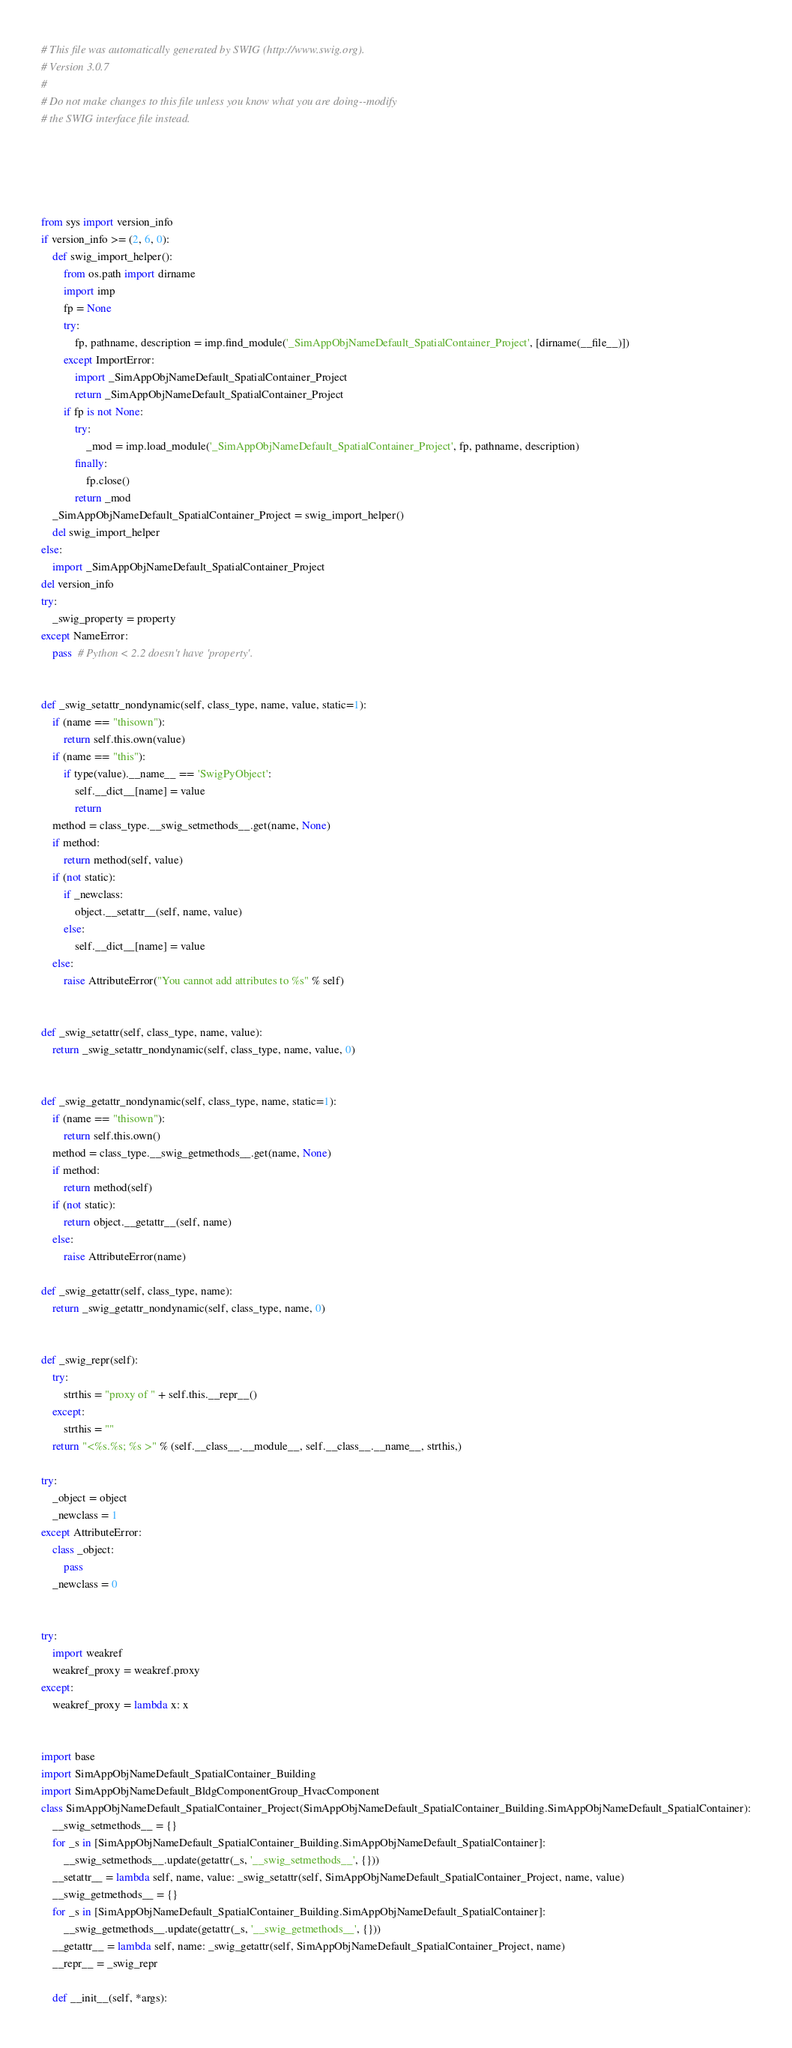Convert code to text. <code><loc_0><loc_0><loc_500><loc_500><_Python_># This file was automatically generated by SWIG (http://www.swig.org).
# Version 3.0.7
#
# Do not make changes to this file unless you know what you are doing--modify
# the SWIG interface file instead.





from sys import version_info
if version_info >= (2, 6, 0):
    def swig_import_helper():
        from os.path import dirname
        import imp
        fp = None
        try:
            fp, pathname, description = imp.find_module('_SimAppObjNameDefault_SpatialContainer_Project', [dirname(__file__)])
        except ImportError:
            import _SimAppObjNameDefault_SpatialContainer_Project
            return _SimAppObjNameDefault_SpatialContainer_Project
        if fp is not None:
            try:
                _mod = imp.load_module('_SimAppObjNameDefault_SpatialContainer_Project', fp, pathname, description)
            finally:
                fp.close()
            return _mod
    _SimAppObjNameDefault_SpatialContainer_Project = swig_import_helper()
    del swig_import_helper
else:
    import _SimAppObjNameDefault_SpatialContainer_Project
del version_info
try:
    _swig_property = property
except NameError:
    pass  # Python < 2.2 doesn't have 'property'.


def _swig_setattr_nondynamic(self, class_type, name, value, static=1):
    if (name == "thisown"):
        return self.this.own(value)
    if (name == "this"):
        if type(value).__name__ == 'SwigPyObject':
            self.__dict__[name] = value
            return
    method = class_type.__swig_setmethods__.get(name, None)
    if method:
        return method(self, value)
    if (not static):
        if _newclass:
            object.__setattr__(self, name, value)
        else:
            self.__dict__[name] = value
    else:
        raise AttributeError("You cannot add attributes to %s" % self)


def _swig_setattr(self, class_type, name, value):
    return _swig_setattr_nondynamic(self, class_type, name, value, 0)


def _swig_getattr_nondynamic(self, class_type, name, static=1):
    if (name == "thisown"):
        return self.this.own()
    method = class_type.__swig_getmethods__.get(name, None)
    if method:
        return method(self)
    if (not static):
        return object.__getattr__(self, name)
    else:
        raise AttributeError(name)

def _swig_getattr(self, class_type, name):
    return _swig_getattr_nondynamic(self, class_type, name, 0)


def _swig_repr(self):
    try:
        strthis = "proxy of " + self.this.__repr__()
    except:
        strthis = ""
    return "<%s.%s; %s >" % (self.__class__.__module__, self.__class__.__name__, strthis,)

try:
    _object = object
    _newclass = 1
except AttributeError:
    class _object:
        pass
    _newclass = 0


try:
    import weakref
    weakref_proxy = weakref.proxy
except:
    weakref_proxy = lambda x: x


import base
import SimAppObjNameDefault_SpatialContainer_Building
import SimAppObjNameDefault_BldgComponentGroup_HvacComponent
class SimAppObjNameDefault_SpatialContainer_Project(SimAppObjNameDefault_SpatialContainer_Building.SimAppObjNameDefault_SpatialContainer):
    __swig_setmethods__ = {}
    for _s in [SimAppObjNameDefault_SpatialContainer_Building.SimAppObjNameDefault_SpatialContainer]:
        __swig_setmethods__.update(getattr(_s, '__swig_setmethods__', {}))
    __setattr__ = lambda self, name, value: _swig_setattr(self, SimAppObjNameDefault_SpatialContainer_Project, name, value)
    __swig_getmethods__ = {}
    for _s in [SimAppObjNameDefault_SpatialContainer_Building.SimAppObjNameDefault_SpatialContainer]:
        __swig_getmethods__.update(getattr(_s, '__swig_getmethods__', {}))
    __getattr__ = lambda self, name: _swig_getattr(self, SimAppObjNameDefault_SpatialContainer_Project, name)
    __repr__ = _swig_repr

    def __init__(self, *args):</code> 